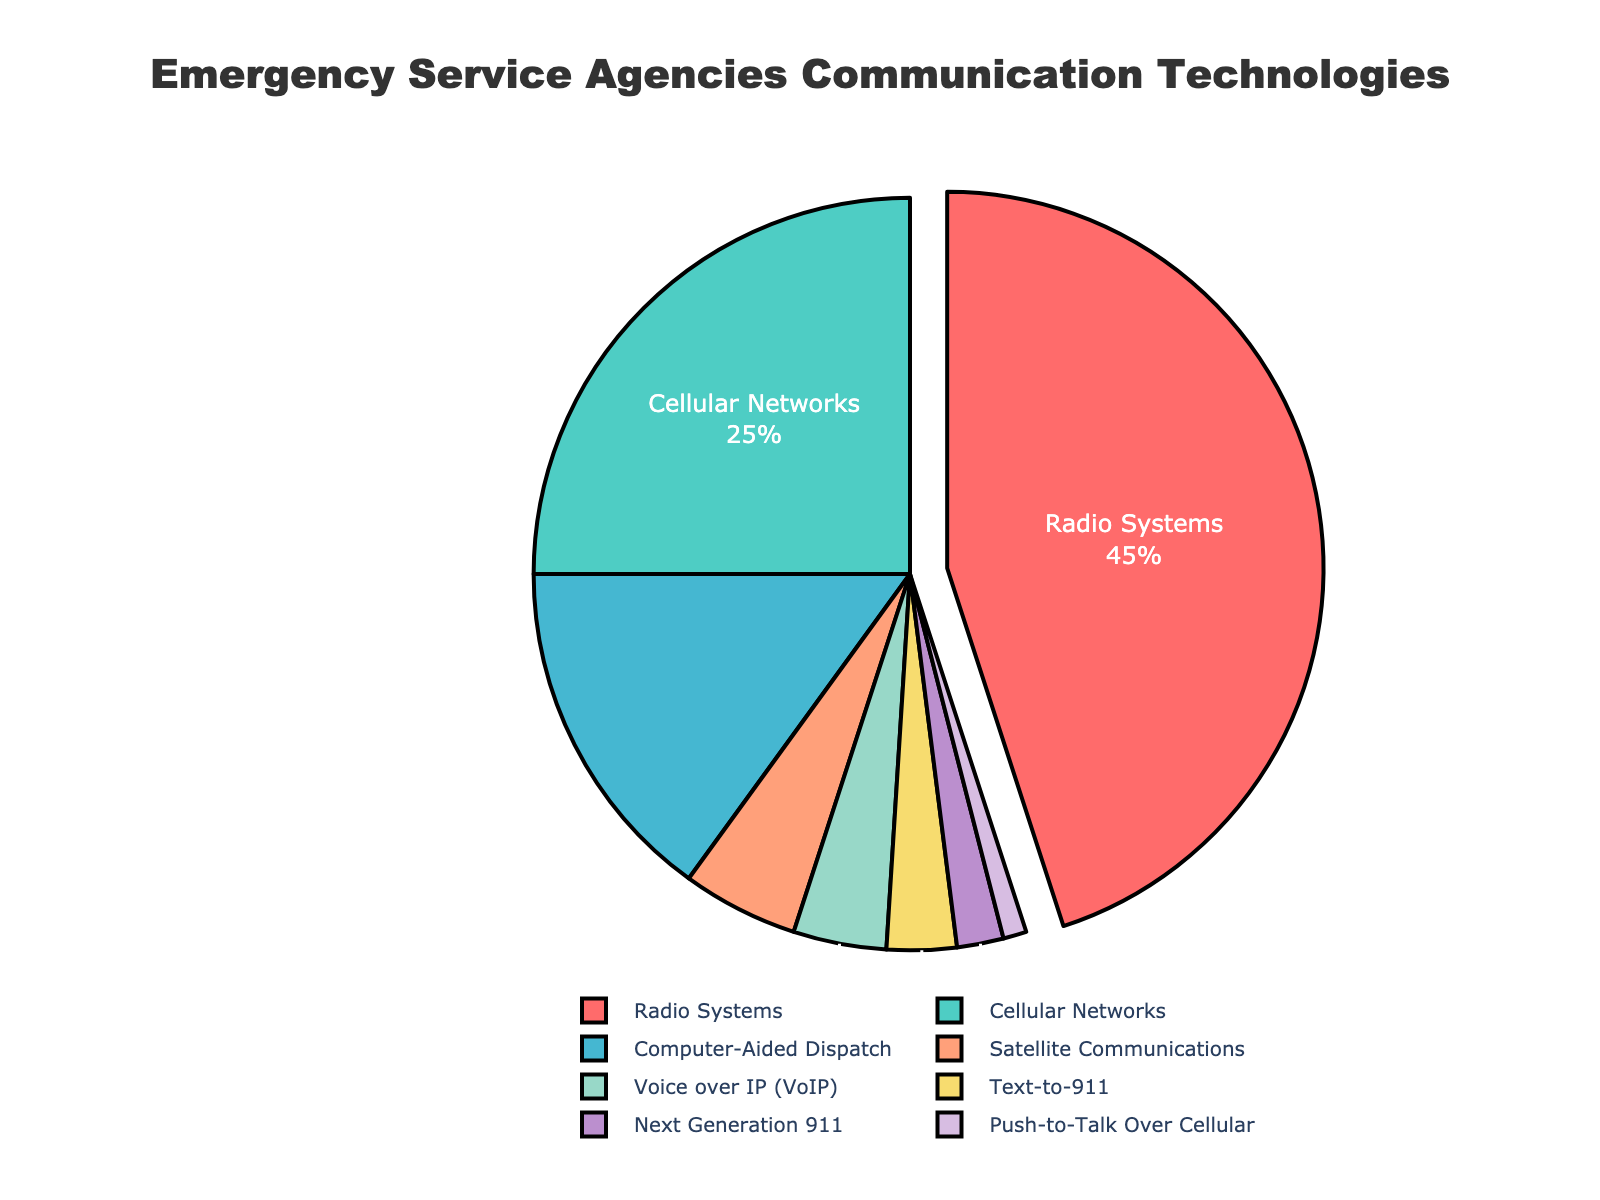What percentage of emergency service agencies use Cellular Networks and Computer-Aided Dispatch combined? To find the combined percentage, add the percentage of Cellular Networks (25) and Computer-Aided Dispatch (15). Therefore, 25 + 15 = 40.
Answer: 40 Which communication technology is used by the fewest emergency service agencies? Look for the smallest percentage in the pie chart data. Push-to-Talk Over Cellular has the lowest percentage at 1%.
Answer: Push-to-Talk Over Cellular How much more popular is Radio Systems compared to Satellite Communications? Subtract the percentage of Satellite Communications (5) from Radio Systems (45). Therefore, 45 - 5 = 40.
Answer: 40 Is there more usage of Voice over IP (VoIP) or Text-to-911 among emergency service agencies? Compare the percentages of VoIP (4) and Text-to-911 (3). Since 4 is greater than 3, VoIP is used more.
Answer: Voice over IP (VoIP) What is the second most common communication technology used by emergency service agencies? Identify the communication technology with the second highest percentage after Radio Systems (45). Cellular Networks have the next highest percentage (25).
Answer: Cellular Networks What is the combined percentage usage of Next Generation 911 and Push-to-Talk Over Cellular? Add the percentages of Next Generation 911 (2) and Push-to-Talk Over Cellular (1). Therefore, 2 + 1 = 3.
Answer: 3 What color is assigned to Radio Systems in the pie chart? The pie chart uses specific colors for each technology. Radio Systems is highlighted and pulled out with the color red.
Answer: Red How much more popular are Cellular Networks compared to Computer-Aided Dispatch? Subtract the percentage of Computer-Aided Dispatch (15) from Cellular Networks (25). Therefore, 25 - 15 = 10.
Answer: 10 What percentage of emergency service agencies use any form of IP-based communication (sum of VoIP and Next Generation 911)? Add the percentages of VoIP (4) and Next Generation 911 (2). Therefore, 4 + 2 = 6.
Answer: 6 